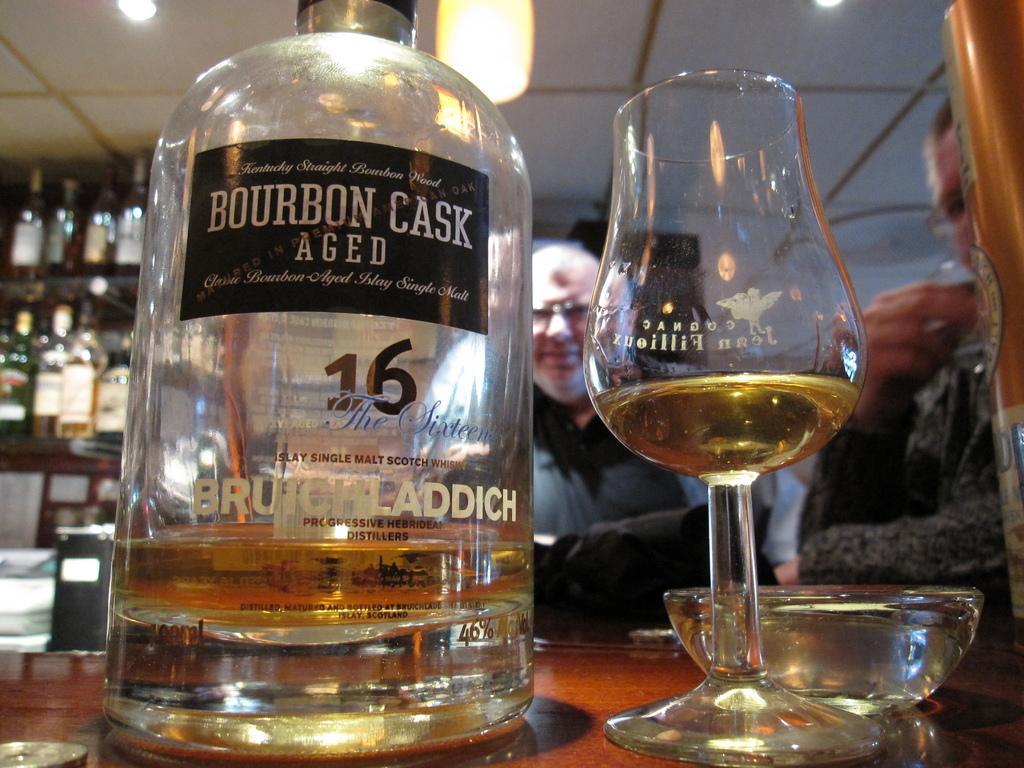Could you give a brief overview of what you see in this image? In this image we can see a glass, bottle and a bowl which are placed on the table. On the backside we can see two people sitting and some bottles which are placed in the racks. We can also see a roof with some ceiling lights. 